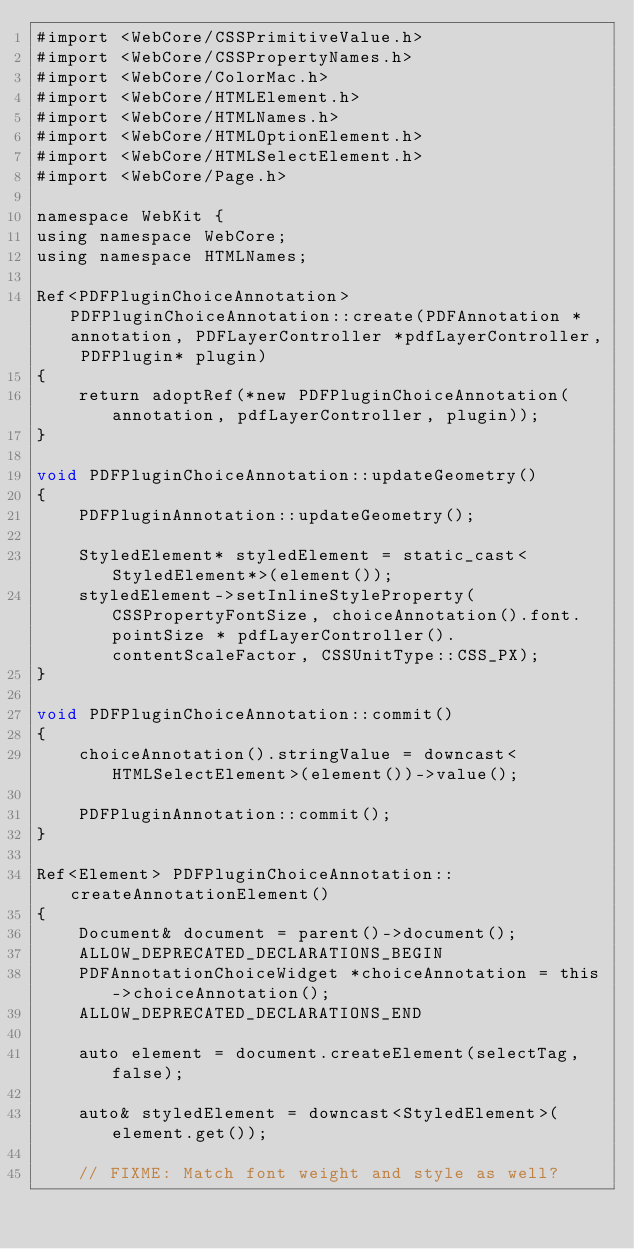Convert code to text. <code><loc_0><loc_0><loc_500><loc_500><_ObjectiveC_>#import <WebCore/CSSPrimitiveValue.h>
#import <WebCore/CSSPropertyNames.h>
#import <WebCore/ColorMac.h>
#import <WebCore/HTMLElement.h>
#import <WebCore/HTMLNames.h>
#import <WebCore/HTMLOptionElement.h>
#import <WebCore/HTMLSelectElement.h>
#import <WebCore/Page.h>

namespace WebKit {
using namespace WebCore;
using namespace HTMLNames;

Ref<PDFPluginChoiceAnnotation> PDFPluginChoiceAnnotation::create(PDFAnnotation *annotation, PDFLayerController *pdfLayerController, PDFPlugin* plugin)
{
    return adoptRef(*new PDFPluginChoiceAnnotation(annotation, pdfLayerController, plugin));
}

void PDFPluginChoiceAnnotation::updateGeometry()
{
    PDFPluginAnnotation::updateGeometry();

    StyledElement* styledElement = static_cast<StyledElement*>(element());
    styledElement->setInlineStyleProperty(CSSPropertyFontSize, choiceAnnotation().font.pointSize * pdfLayerController().contentScaleFactor, CSSUnitType::CSS_PX);
}

void PDFPluginChoiceAnnotation::commit()
{
    choiceAnnotation().stringValue = downcast<HTMLSelectElement>(element())->value();

    PDFPluginAnnotation::commit();
}

Ref<Element> PDFPluginChoiceAnnotation::createAnnotationElement()
{
    Document& document = parent()->document();
    ALLOW_DEPRECATED_DECLARATIONS_BEGIN
    PDFAnnotationChoiceWidget *choiceAnnotation = this->choiceAnnotation();
    ALLOW_DEPRECATED_DECLARATIONS_END

    auto element = document.createElement(selectTag, false);

    auto& styledElement = downcast<StyledElement>(element.get());

    // FIXME: Match font weight and style as well?</code> 